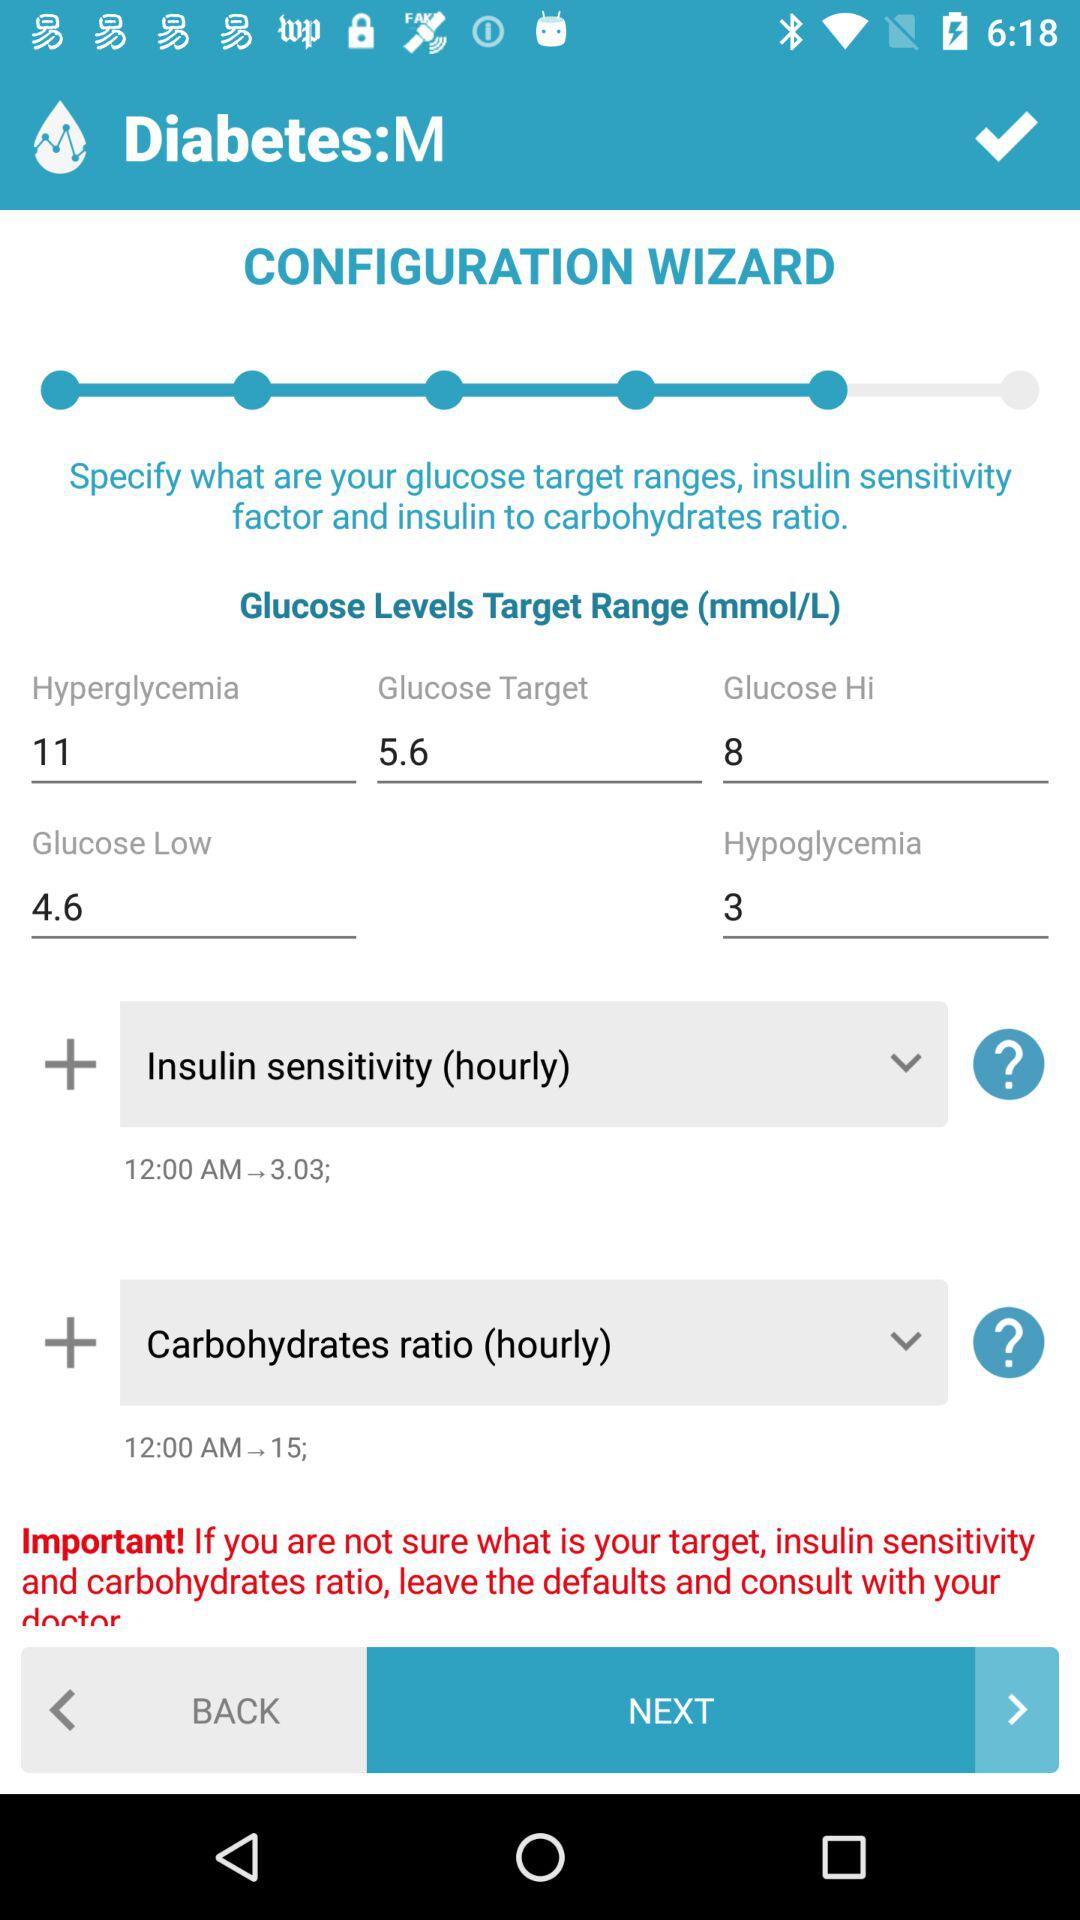What is the Glucose target level? The Glucose target level is 5.6. 